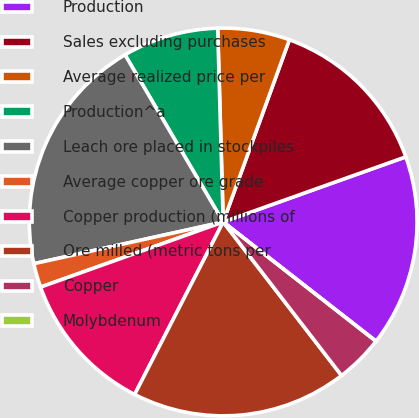<chart> <loc_0><loc_0><loc_500><loc_500><pie_chart><fcel>Production<fcel>Sales excluding purchases<fcel>Average realized price per<fcel>Production^a<fcel>Leach ore placed in stockpiles<fcel>Average copper ore grade<fcel>Copper production (millions of<fcel>Ore milled (metric tons per<fcel>Copper<fcel>Molybdenum<nl><fcel>16.0%<fcel>14.0%<fcel>6.0%<fcel>8.0%<fcel>20.0%<fcel>2.0%<fcel>12.0%<fcel>18.0%<fcel>4.0%<fcel>0.0%<nl></chart> 